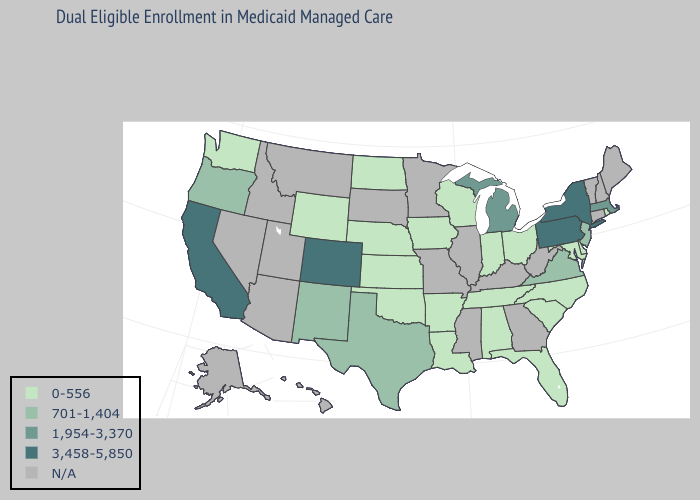What is the value of Vermont?
Give a very brief answer. N/A. Name the states that have a value in the range N/A?
Write a very short answer. Alaska, Arizona, Connecticut, Georgia, Hawaii, Idaho, Illinois, Kentucky, Maine, Minnesota, Mississippi, Missouri, Montana, Nevada, New Hampshire, South Dakota, Utah, Vermont, West Virginia. Name the states that have a value in the range N/A?
Quick response, please. Alaska, Arizona, Connecticut, Georgia, Hawaii, Idaho, Illinois, Kentucky, Maine, Minnesota, Mississippi, Missouri, Montana, Nevada, New Hampshire, South Dakota, Utah, Vermont, West Virginia. Among the states that border Nevada , does Oregon have the highest value?
Quick response, please. No. What is the value of South Carolina?
Keep it brief. 0-556. Does the map have missing data?
Keep it brief. Yes. Name the states that have a value in the range 701-1,404?
Be succinct. New Jersey, New Mexico, Oregon, Texas, Virginia. Which states have the highest value in the USA?
Concise answer only. California, Colorado, New York, Pennsylvania. What is the highest value in the MidWest ?
Be succinct. 1,954-3,370. Among the states that border Louisiana , which have the lowest value?
Concise answer only. Arkansas. What is the value of Minnesota?
Be succinct. N/A. 